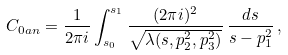<formula> <loc_0><loc_0><loc_500><loc_500>C _ { 0 a n } = \frac { 1 } { 2 \pi i } \int _ { s _ { 0 } } ^ { s _ { 1 } } \frac { ( 2 \pi i ) ^ { 2 } } { \sqrt { \lambda ( s , p _ { 2 } ^ { 2 } , p _ { 3 } ^ { 2 } ) } } \, \frac { d s } { s - p _ { 1 } ^ { 2 } } \, ,</formula> 